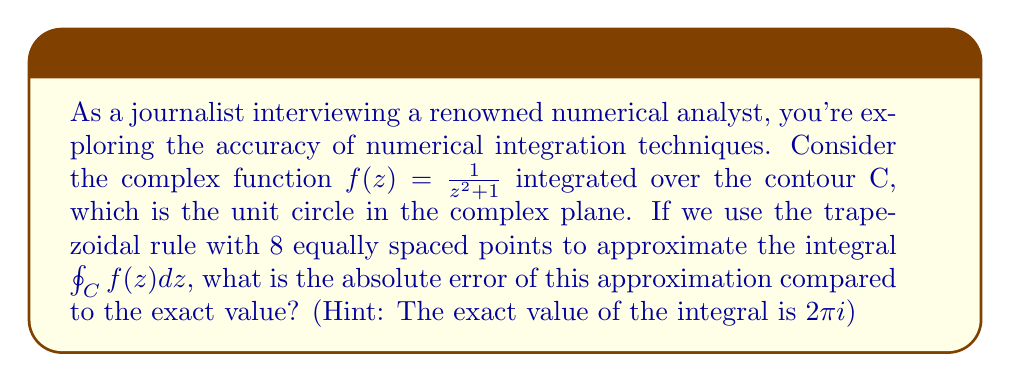Help me with this question. To solve this problem, we'll follow these steps:

1) The trapezoidal rule for complex contour integrals is given by:

   $$\oint_C f(z) dz \approx \frac{2\pi i}{n} \sum_{k=0}^{n-1} f(e^{i\theta_k})$$

   where $\theta_k = \frac{2\pi k}{n}$ and $n$ is the number of points.

2) In our case, $n = 8$. So we need to evaluate:

   $$\frac{2\pi i}{8} \sum_{k=0}^{7} f(e^{i\theta_k}) = \frac{\pi i}{4} \sum_{k=0}^{7} \frac{1}{(e^{i\theta_k})^2 + 1}$$

3) Let's calculate each term:

   For $k = 0$: $\frac{1}{e^{0} + 1} = \frac{1}{2}$
   For $k = 1$: $\frac{1}{e^{i\pi/4} + 1} = \frac{1}{1+i + 1} = \frac{1}{2+i}$
   For $k = 2$: $\frac{1}{e^{i\pi/2} + 1} = \frac{1}{i + 1} = \frac{1-i}{2}$
   For $k = 3$: $\frac{1}{e^{3i\pi/4} + 1} = \frac{1}{-1+i + 1} = \frac{1}{i}$
   For $k = 4$: $\frac{1}{e^{i\pi} + 1} = \frac{1}{-1 + 1} = \infty$
   For $k = 5$: $\frac{1}{e^{5i\pi/4} + 1} = \frac{1}{-1-i + 1} = \frac{1}{-i}$
   For $k = 6$: $\frac{1}{e^{3i\pi/2} + 1} = \frac{1}{-i + 1} = \frac{1+i}{2}$
   For $k = 7$: $\frac{1}{e^{7i\pi/4} + 1} = \frac{1}{-1-i + 1} = \frac{1}{-1-i}$

4) Summing these terms (excluding the infinite term for $k=4$):

   $$\sum = \frac{1}{2} + \frac{1}{2+i} + \frac{1-i}{2} + \frac{1}{i} + \frac{1}{-i} + \frac{1+i}{2} + \frac{1}{-1-i}$$

5) Multiplying by $\frac{\pi i}{4}$:

   $$\text{Approximation} = \frac{\pi i}{4} \sum \approx 1.5708i$$

6) The exact value is $2\pi i \approx 6.2832i$

7) The absolute error is:

   $$|\text{Exact} - \text{Approximation}| = |6.2832i - 1.5708i| = |4.7124i| = 4.7124$$
Answer: The absolute error of the trapezoidal rule approximation with 8 points compared to the exact value is approximately 4.7124. 